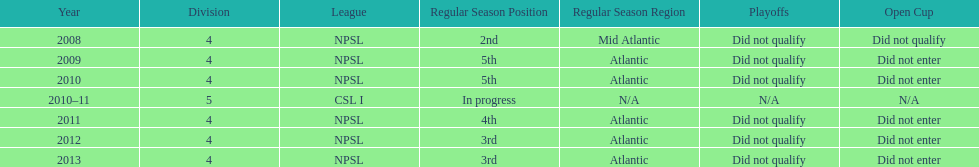What was the last year they were 5th? 2010. 